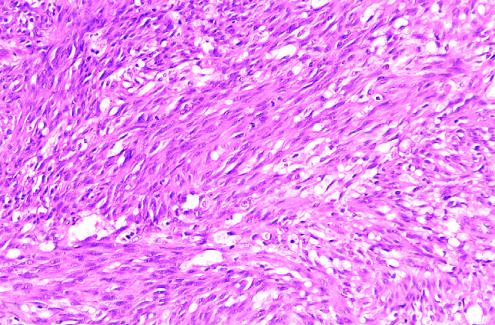did histologic view of the nodular stage demonstrate sheets of plump, proliferating spindle cells and slitlike vascular spaces?
Answer the question using a single word or phrase. Yes 